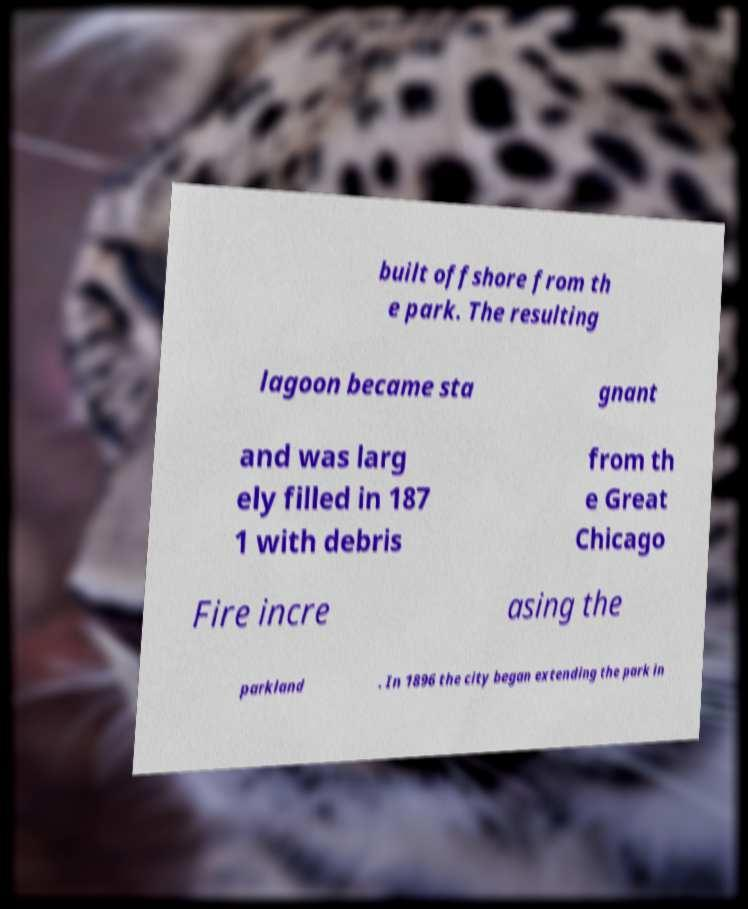Please read and relay the text visible in this image. What does it say? built offshore from th e park. The resulting lagoon became sta gnant and was larg ely filled in 187 1 with debris from th e Great Chicago Fire incre asing the parkland . In 1896 the city began extending the park in 